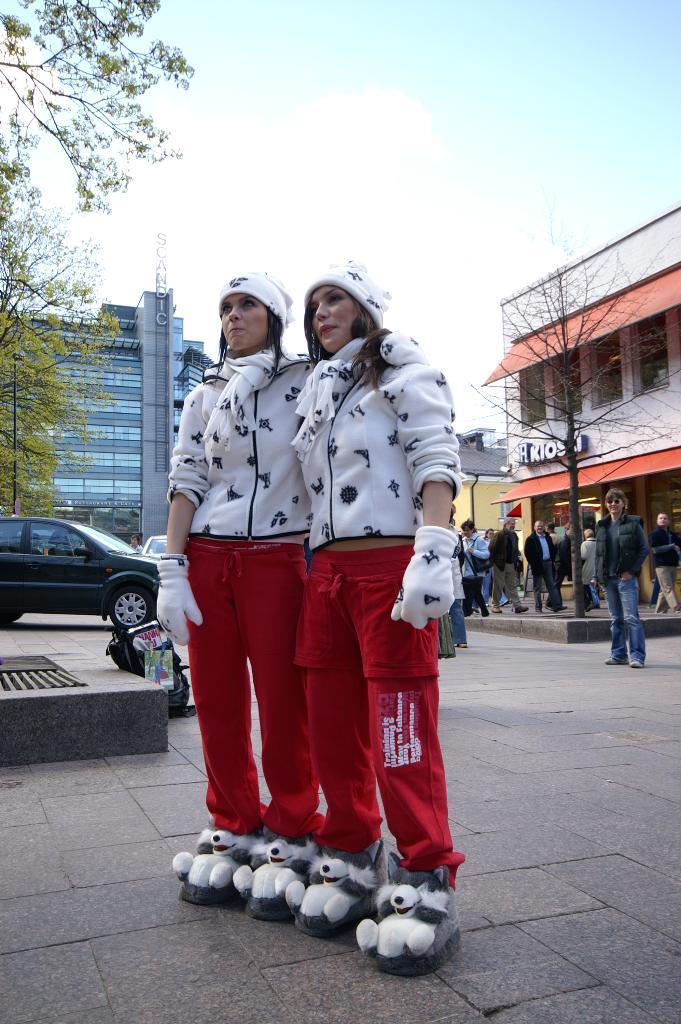How would you summarize this image in a sentence or two? In this image in the foreground there are two women who are standing and they are wearing some costume. In the background there are some buildings vehicles and some persons are walking, at the bottom there is a road and on the top of the image there is sky. 